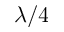<formula> <loc_0><loc_0><loc_500><loc_500>\lambda / 4</formula> 